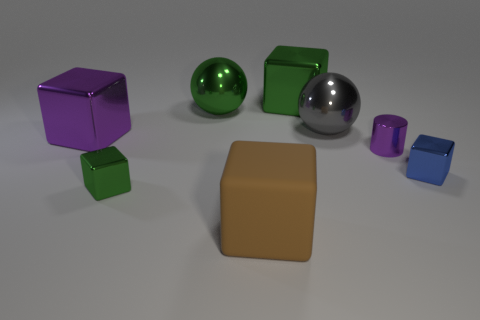What could be the possible uses for the objects in the image within an office setting? The objects could be used as paperweights or desk ornaments in an office setting. Their different shapes and colors might also make them useful for an educational purpose, such as teaching about geometry, colors, and materials. 